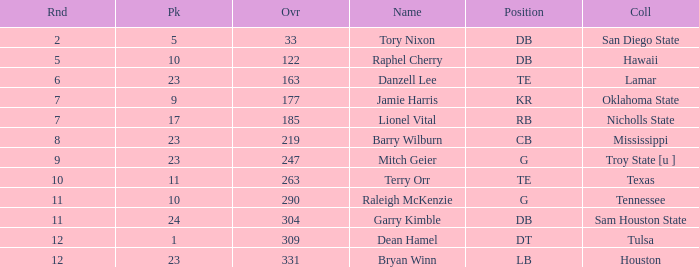Would you mind parsing the complete table? {'header': ['Rnd', 'Pk', 'Ovr', 'Name', 'Position', 'Coll'], 'rows': [['2', '5', '33', 'Tory Nixon', 'DB', 'San Diego State'], ['5', '10', '122', 'Raphel Cherry', 'DB', 'Hawaii'], ['6', '23', '163', 'Danzell Lee', 'TE', 'Lamar'], ['7', '9', '177', 'Jamie Harris', 'KR', 'Oklahoma State'], ['7', '17', '185', 'Lionel Vital', 'RB', 'Nicholls State'], ['8', '23', '219', 'Barry Wilburn', 'CB', 'Mississippi'], ['9', '23', '247', 'Mitch Geier', 'G', 'Troy State [u ]'], ['10', '11', '263', 'Terry Orr', 'TE', 'Texas'], ['11', '10', '290', 'Raleigh McKenzie', 'G', 'Tennessee'], ['11', '24', '304', 'Garry Kimble', 'DB', 'Sam Houston State'], ['12', '1', '309', 'Dean Hamel', 'DT', 'Tulsa'], ['12', '23', '331', 'Bryan Winn', 'LB', 'Houston']]} How many Picks have a College of hawaii, and an Overall smaller than 122? 0.0. 